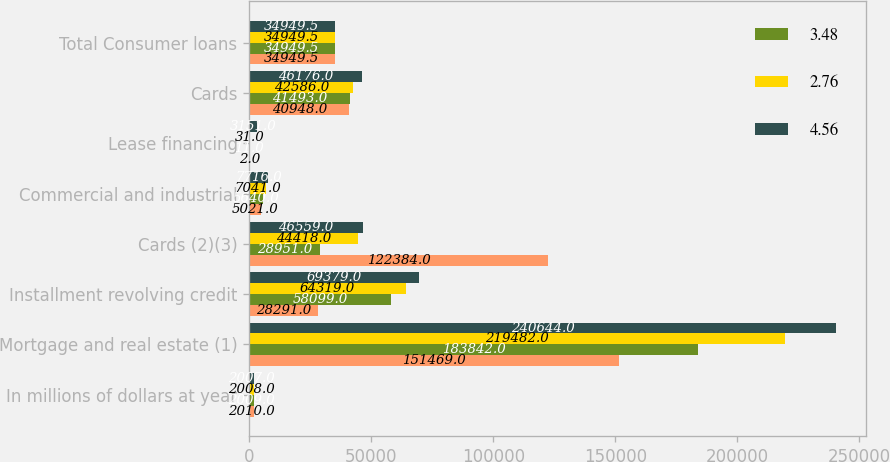<chart> <loc_0><loc_0><loc_500><loc_500><stacked_bar_chart><ecel><fcel>In millions of dollars at year<fcel>Mortgage and real estate (1)<fcel>Installment revolving credit<fcel>Cards (2)(3)<fcel>Commercial and industrial<fcel>Lease financing<fcel>Cards<fcel>Total Consumer loans<nl><fcel>nan<fcel>2010<fcel>151469<fcel>28291<fcel>122384<fcel>5021<fcel>2<fcel>40948<fcel>34949.5<nl><fcel>3.48<fcel>2009<fcel>183842<fcel>58099<fcel>28951<fcel>5640<fcel>11<fcel>41493<fcel>34949.5<nl><fcel>2.76<fcel>2008<fcel>219482<fcel>64319<fcel>44418<fcel>7041<fcel>31<fcel>42586<fcel>34949.5<nl><fcel>4.56<fcel>2007<fcel>240644<fcel>69379<fcel>46559<fcel>7716<fcel>3151<fcel>46176<fcel>34949.5<nl></chart> 